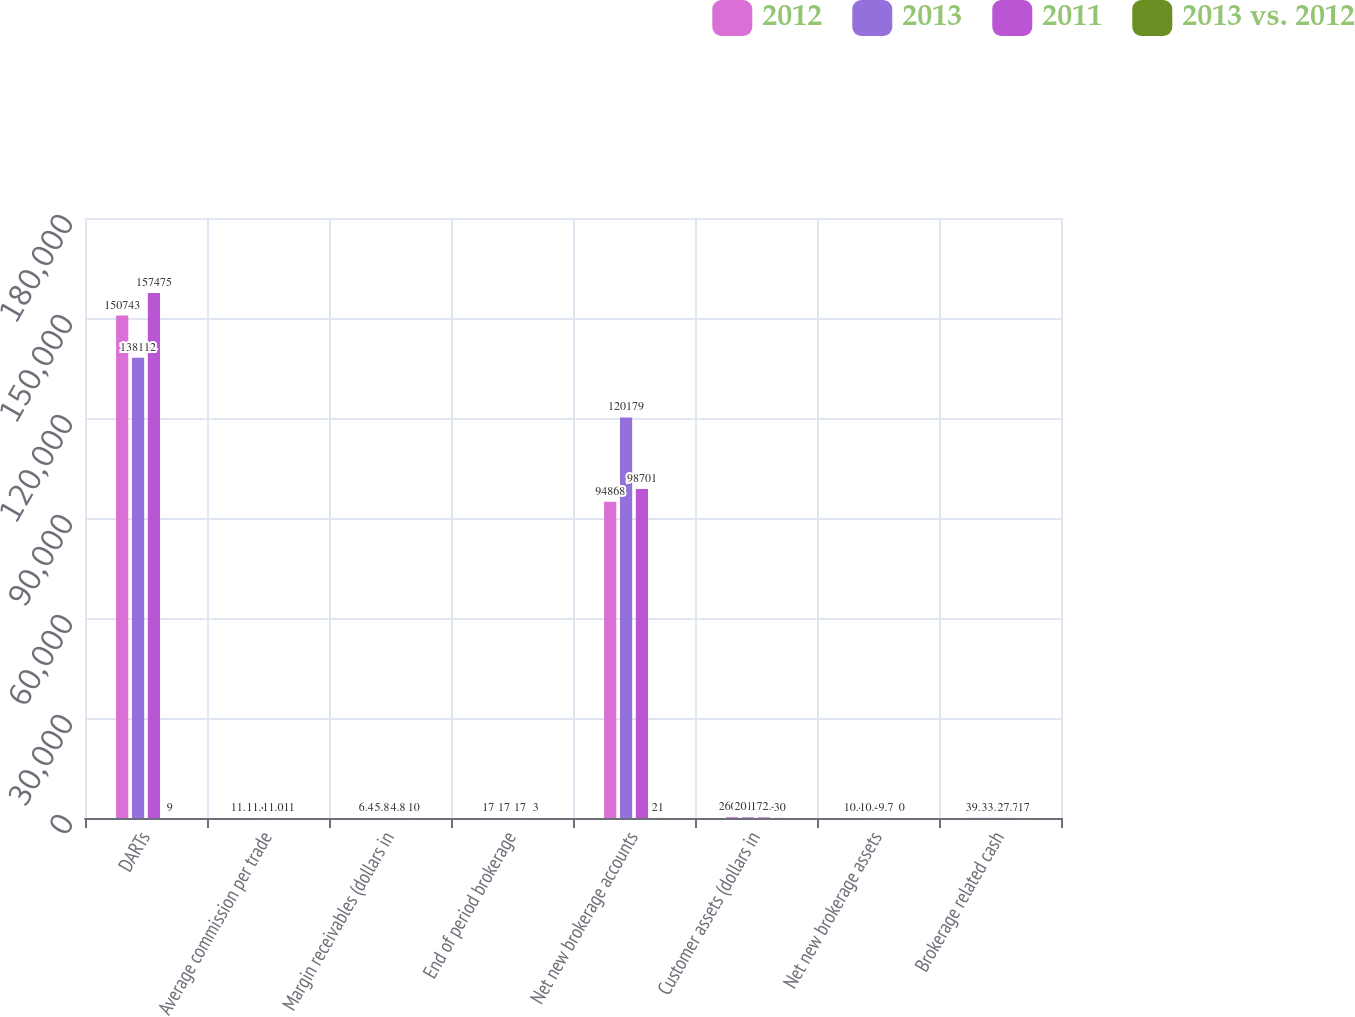Convert chart. <chart><loc_0><loc_0><loc_500><loc_500><stacked_bar_chart><ecel><fcel>DARTs<fcel>Average commission per trade<fcel>Margin receivables (dollars in<fcel>End of period brokerage<fcel>Net new brokerage accounts<fcel>Customer assets (dollars in<fcel>Net new brokerage assets<fcel>Brokerage related cash<nl><fcel>2012<fcel>150743<fcel>11.13<fcel>6.4<fcel>17<fcel>94868<fcel>260.8<fcel>10.4<fcel>39.7<nl><fcel>2013<fcel>138112<fcel>11.01<fcel>5.8<fcel>17<fcel>120179<fcel>201.2<fcel>10.4<fcel>33.9<nl><fcel>2011<fcel>157475<fcel>11.01<fcel>4.8<fcel>17<fcel>98701<fcel>172.4<fcel>9.7<fcel>27.7<nl><fcel>2013 vs. 2012<fcel>9<fcel>1<fcel>10<fcel>3<fcel>21<fcel>30<fcel>0<fcel>17<nl></chart> 